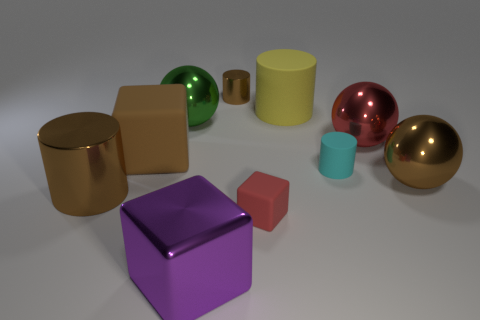Subtract all blocks. How many objects are left? 7 Add 4 big matte cylinders. How many big matte cylinders are left? 5 Add 9 brown matte objects. How many brown matte objects exist? 10 Subtract 2 brown cylinders. How many objects are left? 8 Subtract all big purple objects. Subtract all tiny red rubber cubes. How many objects are left? 8 